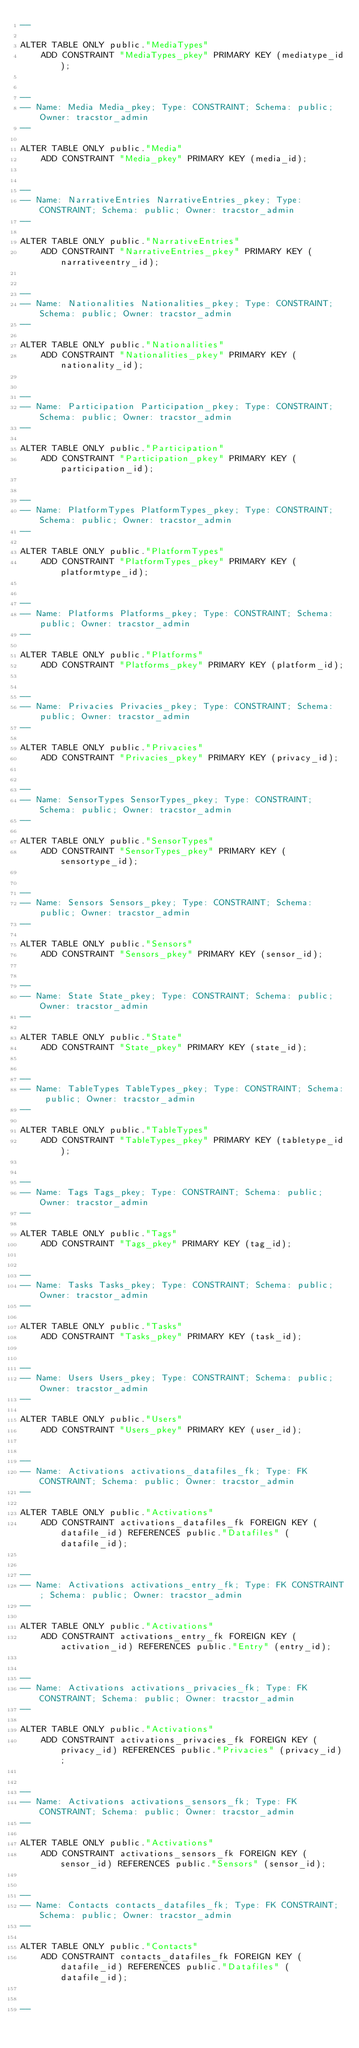<code> <loc_0><loc_0><loc_500><loc_500><_SQL_>--

ALTER TABLE ONLY public."MediaTypes"
    ADD CONSTRAINT "MediaTypes_pkey" PRIMARY KEY (mediatype_id);


--
-- Name: Media Media_pkey; Type: CONSTRAINT; Schema: public; Owner: tracstor_admin
--

ALTER TABLE ONLY public."Media"
    ADD CONSTRAINT "Media_pkey" PRIMARY KEY (media_id);


--
-- Name: NarrativeEntries NarrativeEntries_pkey; Type: CONSTRAINT; Schema: public; Owner: tracstor_admin
--

ALTER TABLE ONLY public."NarrativeEntries"
    ADD CONSTRAINT "NarrativeEntries_pkey" PRIMARY KEY (narrativeentry_id);


--
-- Name: Nationalities Nationalities_pkey; Type: CONSTRAINT; Schema: public; Owner: tracstor_admin
--

ALTER TABLE ONLY public."Nationalities"
    ADD CONSTRAINT "Nationalities_pkey" PRIMARY KEY (nationality_id);


--
-- Name: Participation Participation_pkey; Type: CONSTRAINT; Schema: public; Owner: tracstor_admin
--

ALTER TABLE ONLY public."Participation"
    ADD CONSTRAINT "Participation_pkey" PRIMARY KEY (participation_id);


--
-- Name: PlatformTypes PlatformTypes_pkey; Type: CONSTRAINT; Schema: public; Owner: tracstor_admin
--

ALTER TABLE ONLY public."PlatformTypes"
    ADD CONSTRAINT "PlatformTypes_pkey" PRIMARY KEY (platformtype_id);


--
-- Name: Platforms Platforms_pkey; Type: CONSTRAINT; Schema: public; Owner: tracstor_admin
--

ALTER TABLE ONLY public."Platforms"
    ADD CONSTRAINT "Platforms_pkey" PRIMARY KEY (platform_id);


--
-- Name: Privacies Privacies_pkey; Type: CONSTRAINT; Schema: public; Owner: tracstor_admin
--

ALTER TABLE ONLY public."Privacies"
    ADD CONSTRAINT "Privacies_pkey" PRIMARY KEY (privacy_id);


--
-- Name: SensorTypes SensorTypes_pkey; Type: CONSTRAINT; Schema: public; Owner: tracstor_admin
--

ALTER TABLE ONLY public."SensorTypes"
    ADD CONSTRAINT "SensorTypes_pkey" PRIMARY KEY (sensortype_id);


--
-- Name: Sensors Sensors_pkey; Type: CONSTRAINT; Schema: public; Owner: tracstor_admin
--

ALTER TABLE ONLY public."Sensors"
    ADD CONSTRAINT "Sensors_pkey" PRIMARY KEY (sensor_id);


--
-- Name: State State_pkey; Type: CONSTRAINT; Schema: public; Owner: tracstor_admin
--

ALTER TABLE ONLY public."State"
    ADD CONSTRAINT "State_pkey" PRIMARY KEY (state_id);


--
-- Name: TableTypes TableTypes_pkey; Type: CONSTRAINT; Schema: public; Owner: tracstor_admin
--

ALTER TABLE ONLY public."TableTypes"
    ADD CONSTRAINT "TableTypes_pkey" PRIMARY KEY (tabletype_id);


--
-- Name: Tags Tags_pkey; Type: CONSTRAINT; Schema: public; Owner: tracstor_admin
--

ALTER TABLE ONLY public."Tags"
    ADD CONSTRAINT "Tags_pkey" PRIMARY KEY (tag_id);


--
-- Name: Tasks Tasks_pkey; Type: CONSTRAINT; Schema: public; Owner: tracstor_admin
--

ALTER TABLE ONLY public."Tasks"
    ADD CONSTRAINT "Tasks_pkey" PRIMARY KEY (task_id);


--
-- Name: Users Users_pkey; Type: CONSTRAINT; Schema: public; Owner: tracstor_admin
--

ALTER TABLE ONLY public."Users"
    ADD CONSTRAINT "Users_pkey" PRIMARY KEY (user_id);


--
-- Name: Activations activations_datafiles_fk; Type: FK CONSTRAINT; Schema: public; Owner: tracstor_admin
--

ALTER TABLE ONLY public."Activations"
    ADD CONSTRAINT activations_datafiles_fk FOREIGN KEY (datafile_id) REFERENCES public."Datafiles" (datafile_id);


--
-- Name: Activations activations_entry_fk; Type: FK CONSTRAINT; Schema: public; Owner: tracstor_admin
--

ALTER TABLE ONLY public."Activations"
    ADD CONSTRAINT activations_entry_fk FOREIGN KEY (activation_id) REFERENCES public."Entry" (entry_id);


--
-- Name: Activations activations_privacies_fk; Type: FK CONSTRAINT; Schema: public; Owner: tracstor_admin
--

ALTER TABLE ONLY public."Activations"
    ADD CONSTRAINT activations_privacies_fk FOREIGN KEY (privacy_id) REFERENCES public."Privacies" (privacy_id);


--
-- Name: Activations activations_sensors_fk; Type: FK CONSTRAINT; Schema: public; Owner: tracstor_admin
--

ALTER TABLE ONLY public."Activations"
    ADD CONSTRAINT activations_sensors_fk FOREIGN KEY (sensor_id) REFERENCES public."Sensors" (sensor_id);


--
-- Name: Contacts contacts_datafiles_fk; Type: FK CONSTRAINT; Schema: public; Owner: tracstor_admin
--

ALTER TABLE ONLY public."Contacts"
    ADD CONSTRAINT contacts_datafiles_fk FOREIGN KEY (datafile_id) REFERENCES public."Datafiles" (datafile_id);


--</code> 